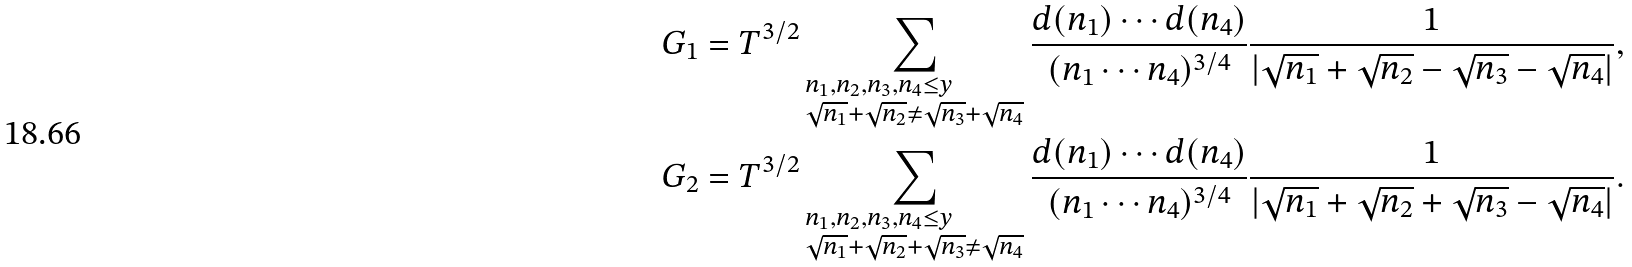<formula> <loc_0><loc_0><loc_500><loc_500>& G _ { 1 } = T ^ { 3 / 2 } \sum _ { \begin{subarray} { c } n _ { 1 } , n _ { 2 } , n _ { 3 } , n _ { 4 } \leq y \\ \sqrt { n _ { 1 } } + \sqrt { n _ { 2 } } \neq \sqrt { n _ { 3 } } + \sqrt { n _ { 4 } } \end{subarray} } \frac { d ( n _ { 1 } ) \cdots d ( n _ { 4 } ) } { ( n _ { 1 } \cdots n _ { 4 } ) ^ { 3 / 4 } } \frac { 1 } { | \sqrt { n _ { 1 } } + \sqrt { n _ { 2 } } - \sqrt { n _ { 3 } } - \sqrt { n _ { 4 } } | } , \\ & G _ { 2 } = T ^ { 3 / 2 } \sum _ { \begin{subarray} { c } n _ { 1 } , n _ { 2 } , n _ { 3 } , n _ { 4 } \leq y \\ \sqrt { n _ { 1 } } + \sqrt { n _ { 2 } } + \sqrt { n _ { 3 } } \neq \sqrt { n _ { 4 } } \end{subarray} } \frac { d ( n _ { 1 } ) \cdots d ( n _ { 4 } ) } { ( n _ { 1 } \cdots n _ { 4 } ) ^ { 3 / 4 } } \frac { 1 } { | \sqrt { n _ { 1 } } + \sqrt { n _ { 2 } } + \sqrt { n _ { 3 } } - \sqrt { n _ { 4 } } | } .</formula> 